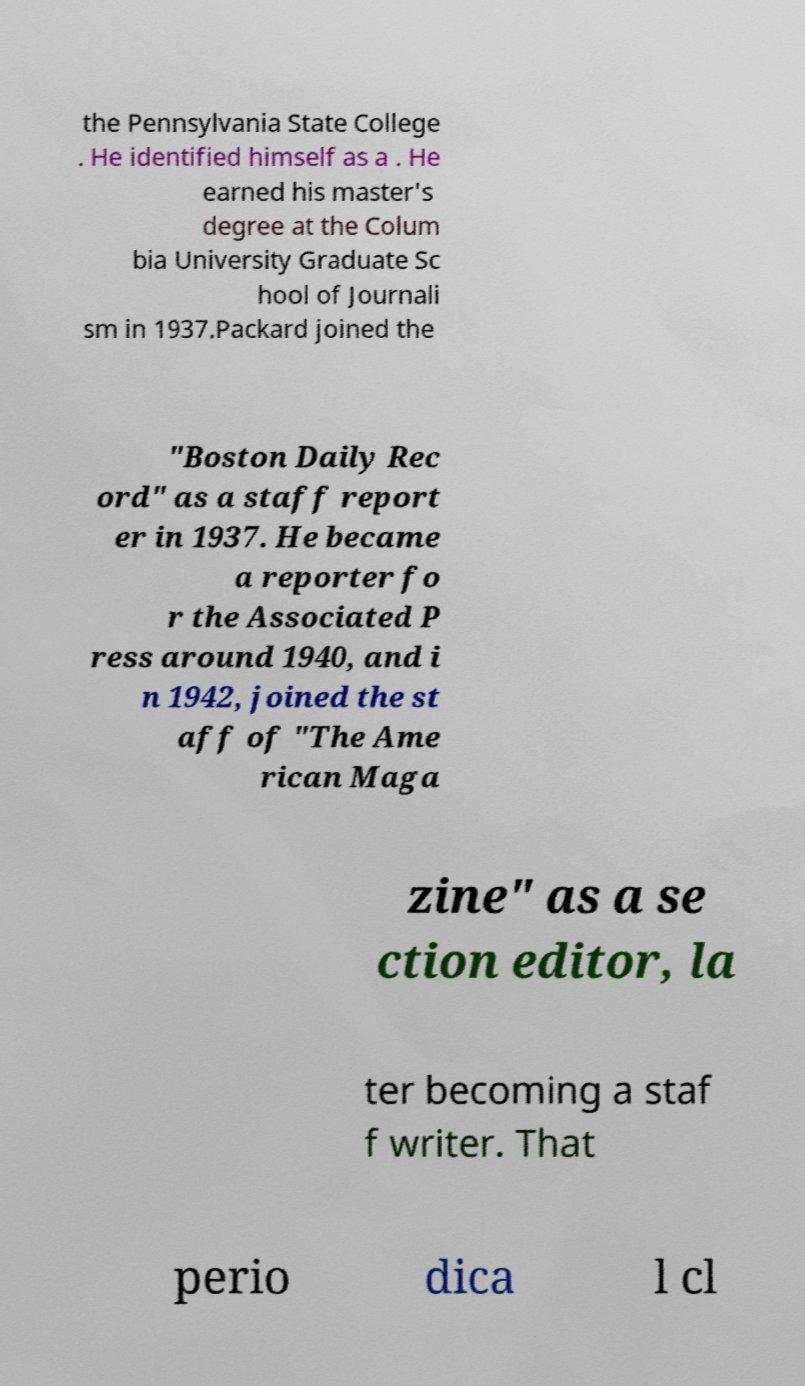Could you extract and type out the text from this image? the Pennsylvania State College . He identified himself as a . He earned his master's degree at the Colum bia University Graduate Sc hool of Journali sm in 1937.Packard joined the "Boston Daily Rec ord" as a staff report er in 1937. He became a reporter fo r the Associated P ress around 1940, and i n 1942, joined the st aff of "The Ame rican Maga zine" as a se ction editor, la ter becoming a staf f writer. That perio dica l cl 